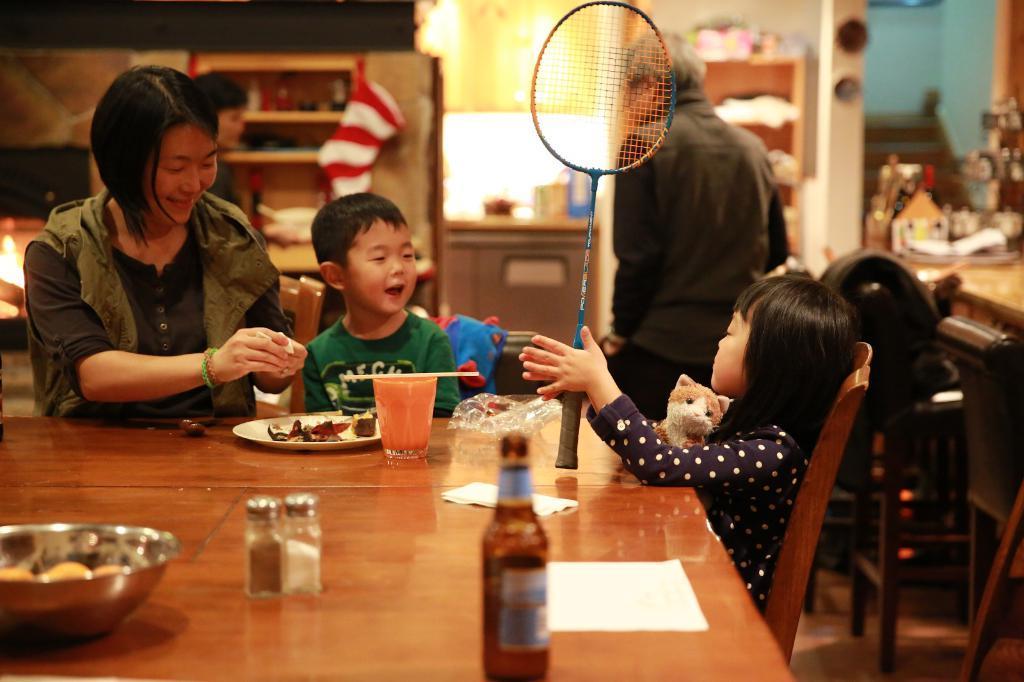Could you give a brief overview of what you see in this image? It is a closed where in the middle three people are sitting on the chairs and in front of them there is a table on which glasses, bottles and plates are present, at the right corner one girl is holding a bat in her hands and there is one man is standing in the black dress and in front of the man there are shelves, another room and desk is present. 